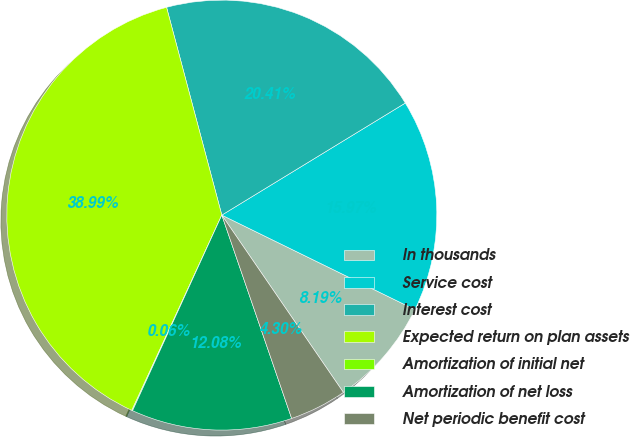<chart> <loc_0><loc_0><loc_500><loc_500><pie_chart><fcel>In thousands<fcel>Service cost<fcel>Interest cost<fcel>Expected return on plan assets<fcel>Amortization of initial net<fcel>Amortization of net loss<fcel>Net periodic benefit cost<nl><fcel>8.19%<fcel>15.97%<fcel>20.41%<fcel>38.99%<fcel>0.06%<fcel>12.08%<fcel>4.3%<nl></chart> 